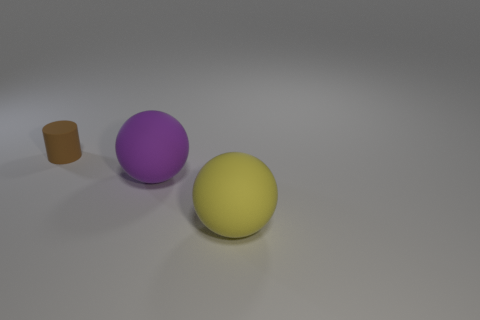Add 2 small green things. How many objects exist? 5 Subtract all cylinders. How many objects are left? 2 Subtract all big purple metallic blocks. Subtract all purple balls. How many objects are left? 2 Add 1 big purple matte spheres. How many big purple matte spheres are left? 2 Add 1 large purple rubber objects. How many large purple rubber objects exist? 2 Subtract 1 brown cylinders. How many objects are left? 2 